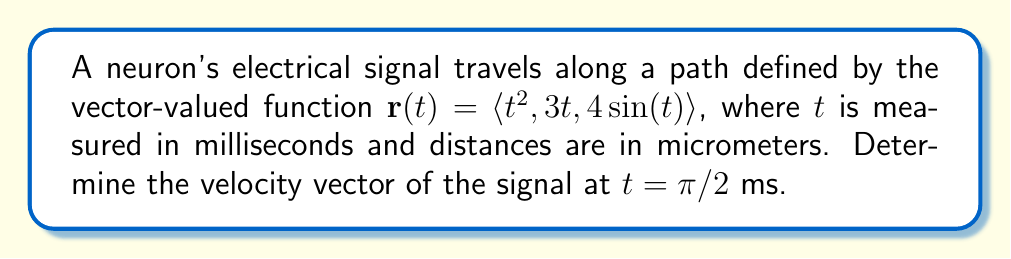Can you answer this question? To solve this problem, we need to follow these steps:

1) The velocity vector is the first derivative of the position vector with respect to time. We can find this by differentiating each component of $\mathbf{r}(t)$.

2) Let's start by writing out $\mathbf{r}(t)$:
   $$\mathbf{r}(t) = \langle t^2, 3t, 4\sin(t) \rangle$$

3) Now, let's differentiate each component:
   - For $t^2$: The derivative is $2t$
   - For $3t$: The derivative is $3$
   - For $4\sin(t)$: The derivative is $4\cos(t)$

4) Therefore, the velocity vector $\mathbf{v}(t)$ is:
   $$\mathbf{v}(t) = \mathbf{r}'(t) = \langle 2t, 3, 4\cos(t) \rangle$$

5) We need to evaluate this at $t = \pi/2$. Let's substitute this value:
   $$\mathbf{v}(\pi/2) = \langle 2(\pi/2), 3, 4\cos(\pi/2) \rangle$$

6) Simplify:
   - $2(\pi/2) = \pi$
   - $\cos(\pi/2) = 0$

7) Therefore, our final velocity vector is:
   $$\mathbf{v}(\pi/2) = \langle \pi, 3, 0 \rangle$$

This vector represents the instantaneous velocity of the neuron's electrical signal at $t = \pi/2$ ms, measured in micrometers per millisecond.
Answer: $\mathbf{v}(\pi/2) = \langle \pi, 3, 0 \rangle$ μm/ms 